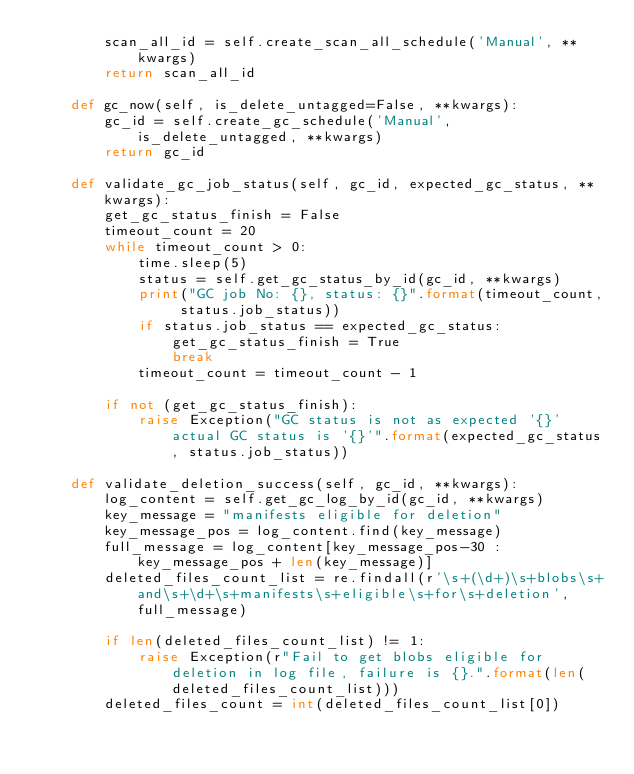Convert code to text. <code><loc_0><loc_0><loc_500><loc_500><_Python_>        scan_all_id = self.create_scan_all_schedule('Manual', **kwargs)
        return scan_all_id

    def gc_now(self, is_delete_untagged=False, **kwargs):
        gc_id = self.create_gc_schedule('Manual', is_delete_untagged, **kwargs)
        return gc_id

    def validate_gc_job_status(self, gc_id, expected_gc_status, **kwargs):
        get_gc_status_finish = False
        timeout_count = 20
        while timeout_count > 0:
            time.sleep(5)
            status = self.get_gc_status_by_id(gc_id, **kwargs)
            print("GC job No: {}, status: {}".format(timeout_count, status.job_status))
            if status.job_status == expected_gc_status:
                get_gc_status_finish = True
                break
            timeout_count = timeout_count - 1

        if not (get_gc_status_finish):
            raise Exception("GC status is not as expected '{}' actual GC status is '{}'".format(expected_gc_status, status.job_status))

    def validate_deletion_success(self, gc_id, **kwargs):
        log_content = self.get_gc_log_by_id(gc_id, **kwargs)
        key_message = "manifests eligible for deletion"
        key_message_pos = log_content.find(key_message)
        full_message = log_content[key_message_pos-30 : key_message_pos + len(key_message)]
        deleted_files_count_list = re.findall(r'\s+(\d+)\s+blobs\s+and\s+\d+\s+manifests\s+eligible\s+for\s+deletion', full_message)

        if len(deleted_files_count_list) != 1:
            raise Exception(r"Fail to get blobs eligible for deletion in log file, failure is {}.".format(len(deleted_files_count_list)))
        deleted_files_count = int(deleted_files_count_list[0])</code> 